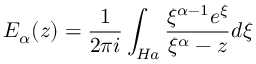<formula> <loc_0><loc_0><loc_500><loc_500>E _ { \alpha } ( z ) = \frac { 1 } { 2 \pi i } \int _ { H a } \frac { \xi ^ { \alpha - 1 } e ^ { \xi } } { \xi ^ { \alpha } - z } d \xi</formula> 